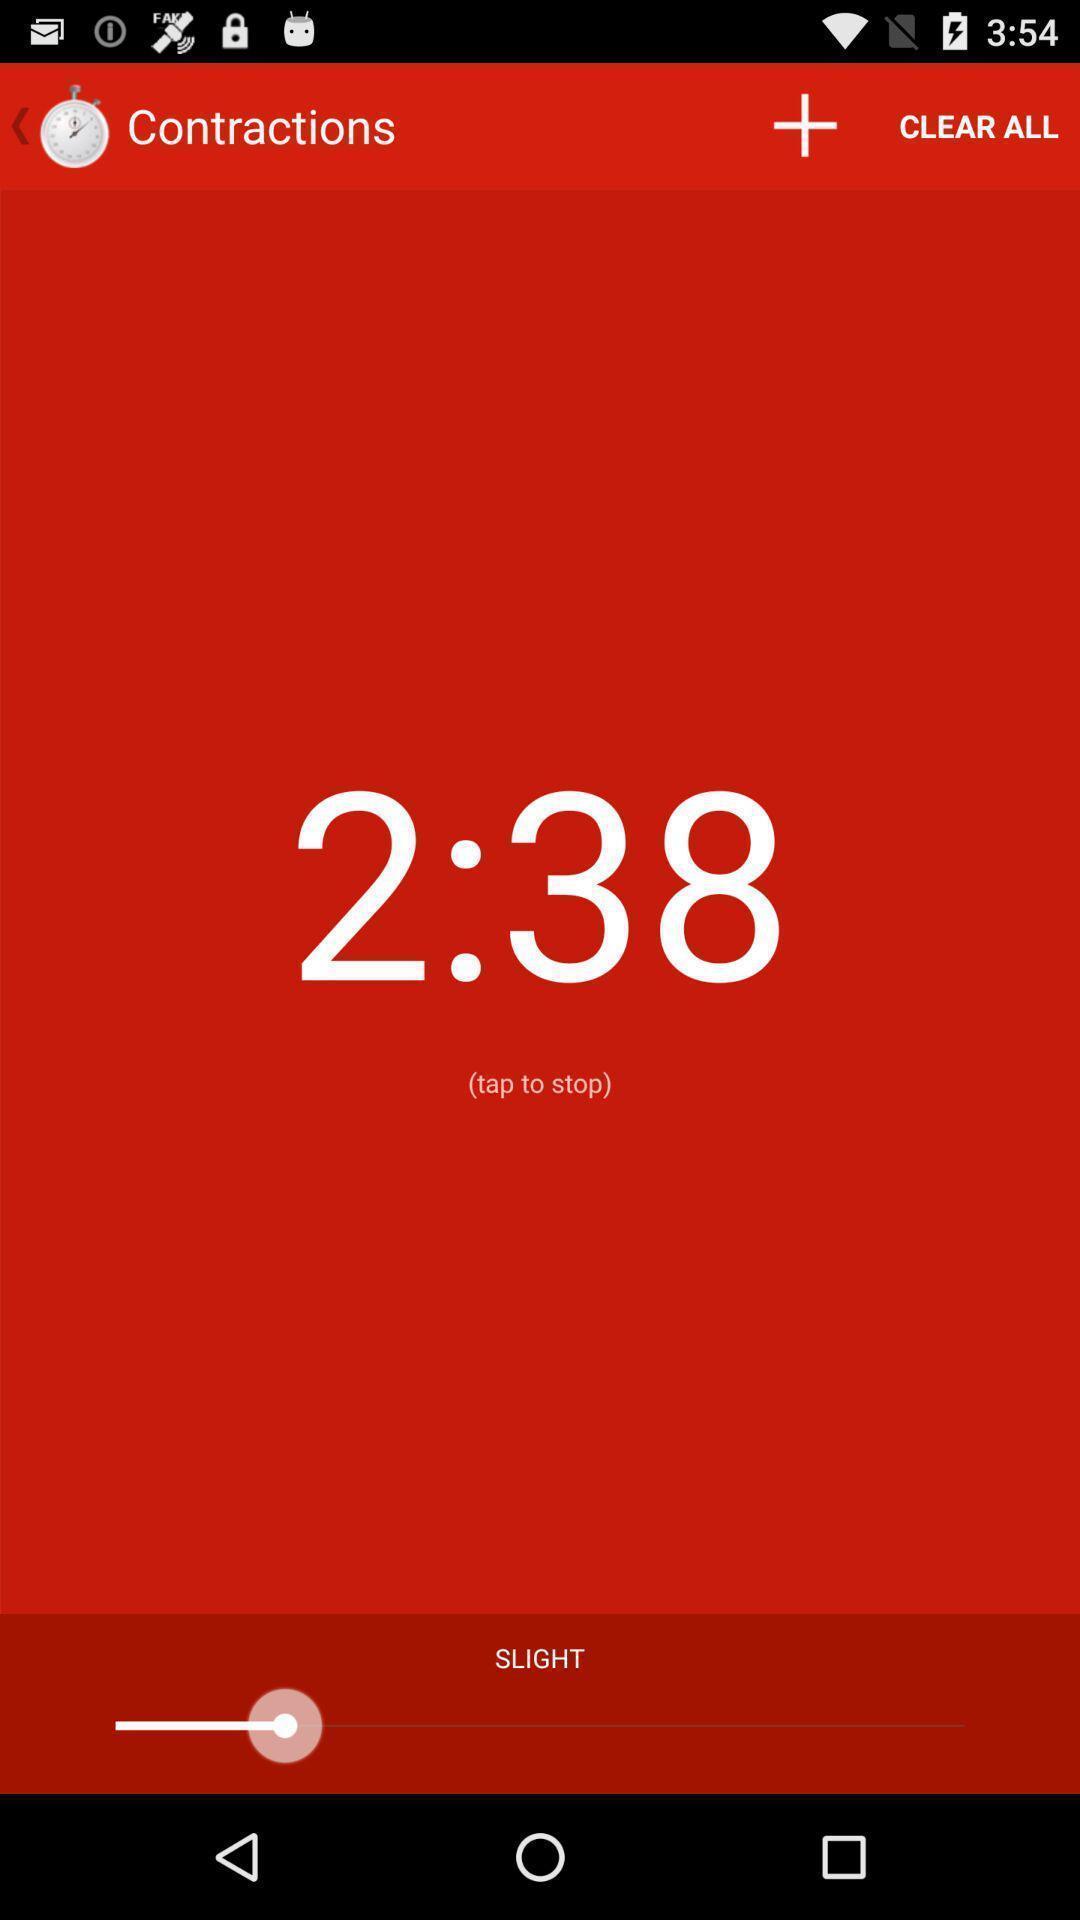Provide a description of this screenshot. Page showing information about pregnancy. 